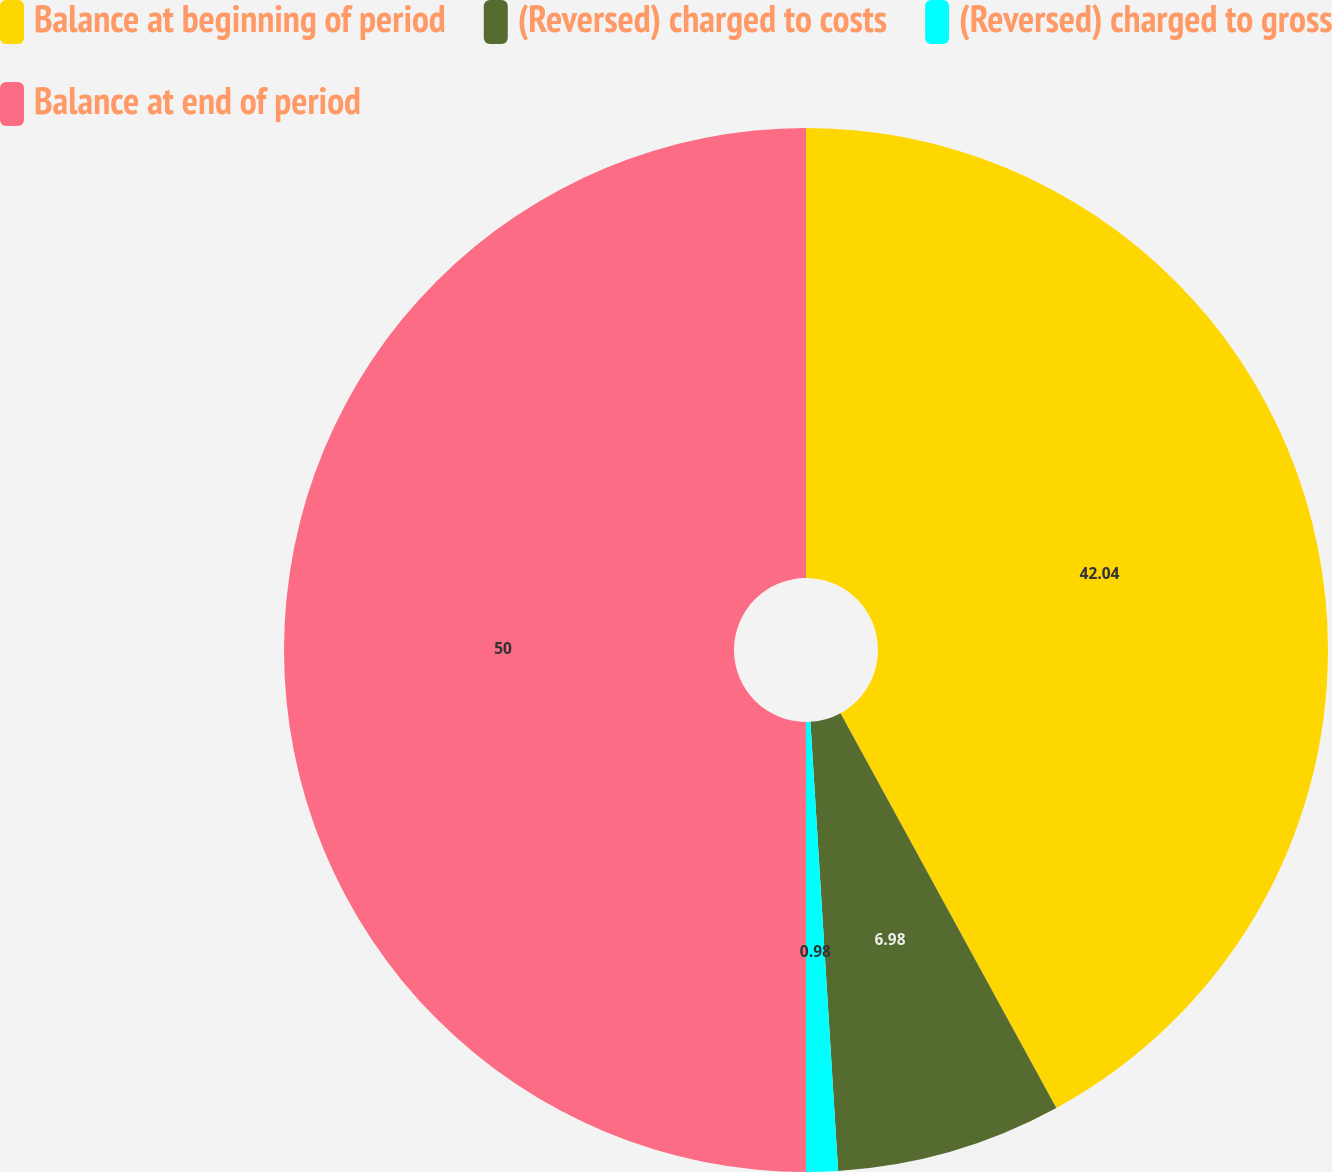Convert chart. <chart><loc_0><loc_0><loc_500><loc_500><pie_chart><fcel>Balance at beginning of period<fcel>(Reversed) charged to costs<fcel>(Reversed) charged to gross<fcel>Balance at end of period<nl><fcel>42.04%<fcel>6.98%<fcel>0.98%<fcel>50.0%<nl></chart> 